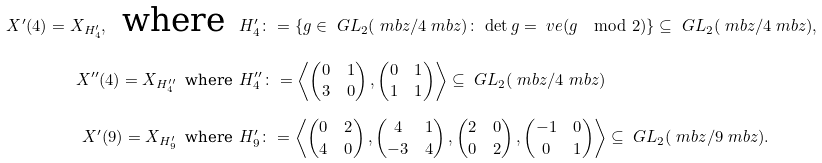Convert formula to latex. <formula><loc_0><loc_0><loc_500><loc_500>X ^ { \prime } ( 4 ) = X _ { H _ { 4 } ^ { \prime } } , \, \text { where } \, & H _ { 4 } ^ { \prime } \colon = \{ g \in \ G L _ { 2 } ( \ m b z / 4 \ m b z ) \colon \, \det g = \ v e ( g \mod 2 ) \} \subseteq \ G L _ { 2 } ( \ m b z / 4 \ m b z ) , \\ X ^ { \prime \prime } ( 4 ) = X _ { H _ { 4 } ^ { \prime \prime } } \, \text { where } \, & H _ { 4 } ^ { \prime \prime } \colon = \left \langle \begin{pmatrix} 0 & 1 \\ 3 & 0 \end{pmatrix} , \begin{pmatrix} 0 & 1 \\ 1 & 1 \end{pmatrix} \right \rangle \subseteq \ G L _ { 2 } ( \ m b z / 4 \ m b z ) \\ X ^ { \prime } ( 9 ) = X _ { H _ { 9 } ^ { \prime } } \, \text { where } \, & H _ { 9 } ^ { \prime } \colon = \left \langle \begin{pmatrix} 0 & 2 \\ 4 & 0 \end{pmatrix} , \begin{pmatrix} 4 & 1 \\ - 3 & 4 \end{pmatrix} , \begin{pmatrix} 2 & 0 \\ 0 & 2 \end{pmatrix} , \begin{pmatrix} - 1 & 0 \\ 0 & 1 \end{pmatrix} \right \rangle \subseteq \ G L _ { 2 } ( \ m b z / 9 \ m b z ) .</formula> 